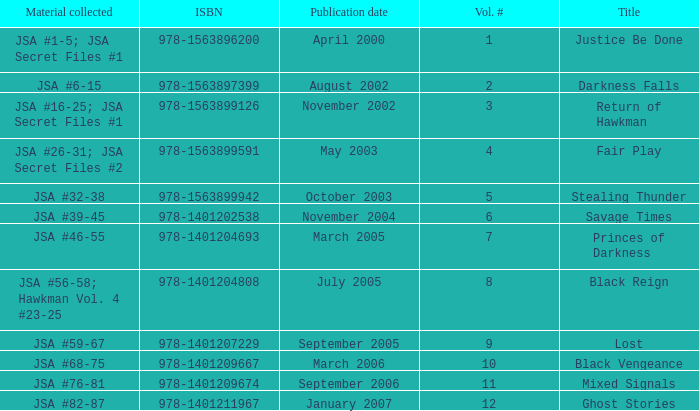What's the Lowest Volume Number that was published November 2004? 6.0. 